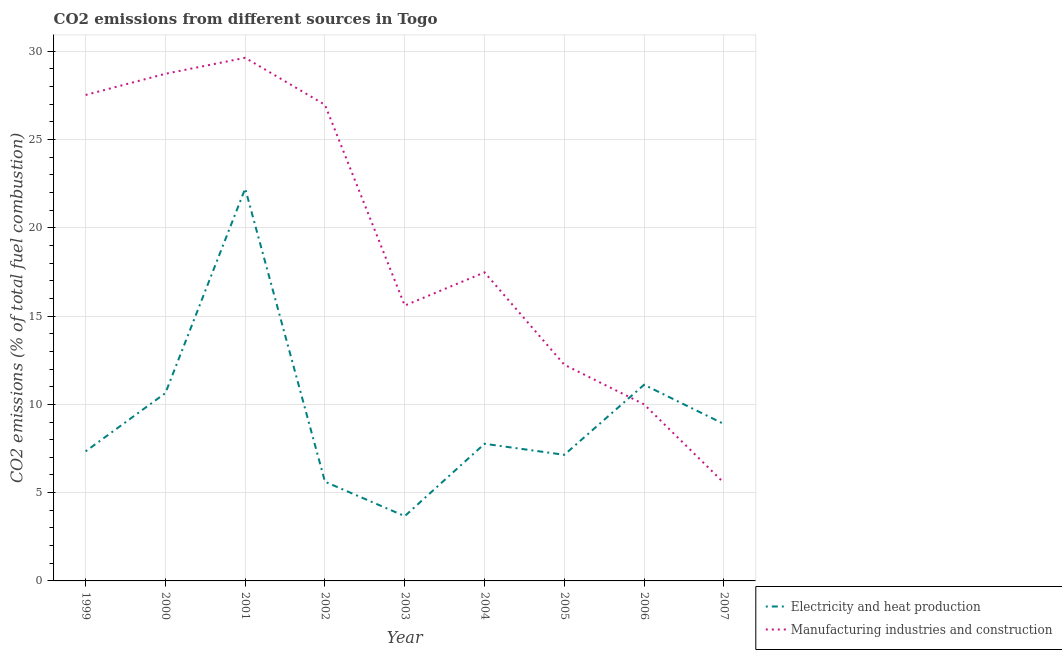Does the line corresponding to co2 emissions due to electricity and heat production intersect with the line corresponding to co2 emissions due to manufacturing industries?
Provide a succinct answer. Yes. What is the co2 emissions due to electricity and heat production in 2005?
Provide a succinct answer. 7.14. Across all years, what is the maximum co2 emissions due to manufacturing industries?
Provide a succinct answer. 29.63. Across all years, what is the minimum co2 emissions due to electricity and heat production?
Ensure brevity in your answer.  3.67. In which year was the co2 emissions due to manufacturing industries maximum?
Provide a succinct answer. 2001. In which year was the co2 emissions due to electricity and heat production minimum?
Offer a very short reply. 2003. What is the total co2 emissions due to electricity and heat production in the graph?
Make the answer very short. 84.4. What is the difference between the co2 emissions due to manufacturing industries in 2003 and that in 2007?
Ensure brevity in your answer.  10.04. What is the difference between the co2 emissions due to electricity and heat production in 2003 and the co2 emissions due to manufacturing industries in 2007?
Your answer should be compact. -1.89. What is the average co2 emissions due to manufacturing industries per year?
Ensure brevity in your answer.  19.3. In the year 2007, what is the difference between the co2 emissions due to manufacturing industries and co2 emissions due to electricity and heat production?
Make the answer very short. -3.33. What is the ratio of the co2 emissions due to manufacturing industries in 2001 to that in 2006?
Provide a short and direct response. 2.96. Is the co2 emissions due to manufacturing industries in 2001 less than that in 2006?
Offer a very short reply. No. What is the difference between the highest and the second highest co2 emissions due to electricity and heat production?
Provide a succinct answer. 11.11. What is the difference between the highest and the lowest co2 emissions due to manufacturing industries?
Provide a short and direct response. 24.07. Is the co2 emissions due to electricity and heat production strictly greater than the co2 emissions due to manufacturing industries over the years?
Your answer should be very brief. No. Does the graph contain any zero values?
Your answer should be compact. No. How many legend labels are there?
Make the answer very short. 2. What is the title of the graph?
Offer a terse response. CO2 emissions from different sources in Togo. What is the label or title of the Y-axis?
Make the answer very short. CO2 emissions (% of total fuel combustion). What is the CO2 emissions (% of total fuel combustion) in Electricity and heat production in 1999?
Your response must be concise. 7.34. What is the CO2 emissions (% of total fuel combustion) of Manufacturing industries and construction in 1999?
Make the answer very short. 27.52. What is the CO2 emissions (% of total fuel combustion) in Electricity and heat production in 2000?
Your answer should be compact. 10.64. What is the CO2 emissions (% of total fuel combustion) in Manufacturing industries and construction in 2000?
Provide a succinct answer. 28.72. What is the CO2 emissions (% of total fuel combustion) in Electricity and heat production in 2001?
Offer a very short reply. 22.22. What is the CO2 emissions (% of total fuel combustion) of Manufacturing industries and construction in 2001?
Offer a very short reply. 29.63. What is the CO2 emissions (% of total fuel combustion) in Electricity and heat production in 2002?
Give a very brief answer. 5.62. What is the CO2 emissions (% of total fuel combustion) in Manufacturing industries and construction in 2002?
Give a very brief answer. 26.97. What is the CO2 emissions (% of total fuel combustion) of Electricity and heat production in 2003?
Keep it short and to the point. 3.67. What is the CO2 emissions (% of total fuel combustion) in Manufacturing industries and construction in 2003?
Provide a short and direct response. 15.6. What is the CO2 emissions (% of total fuel combustion) of Electricity and heat production in 2004?
Offer a very short reply. 7.77. What is the CO2 emissions (% of total fuel combustion) in Manufacturing industries and construction in 2004?
Your answer should be very brief. 17.48. What is the CO2 emissions (% of total fuel combustion) of Electricity and heat production in 2005?
Give a very brief answer. 7.14. What is the CO2 emissions (% of total fuel combustion) of Manufacturing industries and construction in 2005?
Your answer should be compact. 12.24. What is the CO2 emissions (% of total fuel combustion) of Electricity and heat production in 2006?
Offer a terse response. 11.11. What is the CO2 emissions (% of total fuel combustion) of Electricity and heat production in 2007?
Ensure brevity in your answer.  8.89. What is the CO2 emissions (% of total fuel combustion) of Manufacturing industries and construction in 2007?
Your answer should be very brief. 5.56. Across all years, what is the maximum CO2 emissions (% of total fuel combustion) in Electricity and heat production?
Make the answer very short. 22.22. Across all years, what is the maximum CO2 emissions (% of total fuel combustion) in Manufacturing industries and construction?
Ensure brevity in your answer.  29.63. Across all years, what is the minimum CO2 emissions (% of total fuel combustion) in Electricity and heat production?
Offer a very short reply. 3.67. Across all years, what is the minimum CO2 emissions (% of total fuel combustion) in Manufacturing industries and construction?
Your response must be concise. 5.56. What is the total CO2 emissions (% of total fuel combustion) of Electricity and heat production in the graph?
Give a very brief answer. 84.4. What is the total CO2 emissions (% of total fuel combustion) of Manufacturing industries and construction in the graph?
Keep it short and to the point. 173.71. What is the difference between the CO2 emissions (% of total fuel combustion) of Electricity and heat production in 1999 and that in 2000?
Keep it short and to the point. -3.3. What is the difference between the CO2 emissions (% of total fuel combustion) in Manufacturing industries and construction in 1999 and that in 2000?
Your response must be concise. -1.2. What is the difference between the CO2 emissions (% of total fuel combustion) of Electricity and heat production in 1999 and that in 2001?
Offer a very short reply. -14.88. What is the difference between the CO2 emissions (% of total fuel combustion) of Manufacturing industries and construction in 1999 and that in 2001?
Make the answer very short. -2.11. What is the difference between the CO2 emissions (% of total fuel combustion) in Electricity and heat production in 1999 and that in 2002?
Your response must be concise. 1.72. What is the difference between the CO2 emissions (% of total fuel combustion) in Manufacturing industries and construction in 1999 and that in 2002?
Your answer should be very brief. 0.56. What is the difference between the CO2 emissions (% of total fuel combustion) in Electricity and heat production in 1999 and that in 2003?
Ensure brevity in your answer.  3.67. What is the difference between the CO2 emissions (% of total fuel combustion) in Manufacturing industries and construction in 1999 and that in 2003?
Make the answer very short. 11.93. What is the difference between the CO2 emissions (% of total fuel combustion) of Electricity and heat production in 1999 and that in 2004?
Provide a succinct answer. -0.43. What is the difference between the CO2 emissions (% of total fuel combustion) of Manufacturing industries and construction in 1999 and that in 2004?
Provide a short and direct response. 10.05. What is the difference between the CO2 emissions (% of total fuel combustion) of Electricity and heat production in 1999 and that in 2005?
Keep it short and to the point. 0.2. What is the difference between the CO2 emissions (% of total fuel combustion) of Manufacturing industries and construction in 1999 and that in 2005?
Make the answer very short. 15.28. What is the difference between the CO2 emissions (% of total fuel combustion) of Electricity and heat production in 1999 and that in 2006?
Keep it short and to the point. -3.77. What is the difference between the CO2 emissions (% of total fuel combustion) of Manufacturing industries and construction in 1999 and that in 2006?
Offer a very short reply. 17.52. What is the difference between the CO2 emissions (% of total fuel combustion) of Electricity and heat production in 1999 and that in 2007?
Provide a short and direct response. -1.55. What is the difference between the CO2 emissions (% of total fuel combustion) of Manufacturing industries and construction in 1999 and that in 2007?
Your answer should be compact. 21.97. What is the difference between the CO2 emissions (% of total fuel combustion) of Electricity and heat production in 2000 and that in 2001?
Offer a very short reply. -11.58. What is the difference between the CO2 emissions (% of total fuel combustion) of Manufacturing industries and construction in 2000 and that in 2001?
Your answer should be compact. -0.91. What is the difference between the CO2 emissions (% of total fuel combustion) in Electricity and heat production in 2000 and that in 2002?
Ensure brevity in your answer.  5.02. What is the difference between the CO2 emissions (% of total fuel combustion) of Manufacturing industries and construction in 2000 and that in 2002?
Offer a very short reply. 1.76. What is the difference between the CO2 emissions (% of total fuel combustion) of Electricity and heat production in 2000 and that in 2003?
Keep it short and to the point. 6.97. What is the difference between the CO2 emissions (% of total fuel combustion) of Manufacturing industries and construction in 2000 and that in 2003?
Give a very brief answer. 13.13. What is the difference between the CO2 emissions (% of total fuel combustion) of Electricity and heat production in 2000 and that in 2004?
Ensure brevity in your answer.  2.87. What is the difference between the CO2 emissions (% of total fuel combustion) in Manufacturing industries and construction in 2000 and that in 2004?
Keep it short and to the point. 11.25. What is the difference between the CO2 emissions (% of total fuel combustion) in Electricity and heat production in 2000 and that in 2005?
Your response must be concise. 3.5. What is the difference between the CO2 emissions (% of total fuel combustion) of Manufacturing industries and construction in 2000 and that in 2005?
Give a very brief answer. 16.48. What is the difference between the CO2 emissions (% of total fuel combustion) of Electricity and heat production in 2000 and that in 2006?
Offer a terse response. -0.47. What is the difference between the CO2 emissions (% of total fuel combustion) of Manufacturing industries and construction in 2000 and that in 2006?
Your response must be concise. 18.72. What is the difference between the CO2 emissions (% of total fuel combustion) in Electricity and heat production in 2000 and that in 2007?
Your answer should be compact. 1.75. What is the difference between the CO2 emissions (% of total fuel combustion) in Manufacturing industries and construction in 2000 and that in 2007?
Give a very brief answer. 23.17. What is the difference between the CO2 emissions (% of total fuel combustion) in Electricity and heat production in 2001 and that in 2002?
Give a very brief answer. 16.6. What is the difference between the CO2 emissions (% of total fuel combustion) in Manufacturing industries and construction in 2001 and that in 2002?
Your response must be concise. 2.66. What is the difference between the CO2 emissions (% of total fuel combustion) in Electricity and heat production in 2001 and that in 2003?
Provide a short and direct response. 18.55. What is the difference between the CO2 emissions (% of total fuel combustion) in Manufacturing industries and construction in 2001 and that in 2003?
Keep it short and to the point. 14.03. What is the difference between the CO2 emissions (% of total fuel combustion) in Electricity and heat production in 2001 and that in 2004?
Offer a very short reply. 14.46. What is the difference between the CO2 emissions (% of total fuel combustion) in Manufacturing industries and construction in 2001 and that in 2004?
Give a very brief answer. 12.15. What is the difference between the CO2 emissions (% of total fuel combustion) of Electricity and heat production in 2001 and that in 2005?
Make the answer very short. 15.08. What is the difference between the CO2 emissions (% of total fuel combustion) of Manufacturing industries and construction in 2001 and that in 2005?
Your answer should be compact. 17.38. What is the difference between the CO2 emissions (% of total fuel combustion) in Electricity and heat production in 2001 and that in 2006?
Your response must be concise. 11.11. What is the difference between the CO2 emissions (% of total fuel combustion) in Manufacturing industries and construction in 2001 and that in 2006?
Make the answer very short. 19.63. What is the difference between the CO2 emissions (% of total fuel combustion) in Electricity and heat production in 2001 and that in 2007?
Your answer should be compact. 13.33. What is the difference between the CO2 emissions (% of total fuel combustion) of Manufacturing industries and construction in 2001 and that in 2007?
Your answer should be very brief. 24.07. What is the difference between the CO2 emissions (% of total fuel combustion) in Electricity and heat production in 2002 and that in 2003?
Make the answer very short. 1.95. What is the difference between the CO2 emissions (% of total fuel combustion) in Manufacturing industries and construction in 2002 and that in 2003?
Your response must be concise. 11.37. What is the difference between the CO2 emissions (% of total fuel combustion) in Electricity and heat production in 2002 and that in 2004?
Make the answer very short. -2.15. What is the difference between the CO2 emissions (% of total fuel combustion) of Manufacturing industries and construction in 2002 and that in 2004?
Make the answer very short. 9.49. What is the difference between the CO2 emissions (% of total fuel combustion) in Electricity and heat production in 2002 and that in 2005?
Make the answer very short. -1.52. What is the difference between the CO2 emissions (% of total fuel combustion) in Manufacturing industries and construction in 2002 and that in 2005?
Provide a short and direct response. 14.72. What is the difference between the CO2 emissions (% of total fuel combustion) in Electricity and heat production in 2002 and that in 2006?
Provide a short and direct response. -5.49. What is the difference between the CO2 emissions (% of total fuel combustion) in Manufacturing industries and construction in 2002 and that in 2006?
Your response must be concise. 16.97. What is the difference between the CO2 emissions (% of total fuel combustion) of Electricity and heat production in 2002 and that in 2007?
Ensure brevity in your answer.  -3.27. What is the difference between the CO2 emissions (% of total fuel combustion) in Manufacturing industries and construction in 2002 and that in 2007?
Give a very brief answer. 21.41. What is the difference between the CO2 emissions (% of total fuel combustion) of Electricity and heat production in 2003 and that in 2004?
Your response must be concise. -4.1. What is the difference between the CO2 emissions (% of total fuel combustion) in Manufacturing industries and construction in 2003 and that in 2004?
Offer a terse response. -1.88. What is the difference between the CO2 emissions (% of total fuel combustion) in Electricity and heat production in 2003 and that in 2005?
Keep it short and to the point. -3.47. What is the difference between the CO2 emissions (% of total fuel combustion) of Manufacturing industries and construction in 2003 and that in 2005?
Give a very brief answer. 3.35. What is the difference between the CO2 emissions (% of total fuel combustion) in Electricity and heat production in 2003 and that in 2006?
Give a very brief answer. -7.44. What is the difference between the CO2 emissions (% of total fuel combustion) of Manufacturing industries and construction in 2003 and that in 2006?
Offer a terse response. 5.6. What is the difference between the CO2 emissions (% of total fuel combustion) of Electricity and heat production in 2003 and that in 2007?
Ensure brevity in your answer.  -5.22. What is the difference between the CO2 emissions (% of total fuel combustion) of Manufacturing industries and construction in 2003 and that in 2007?
Make the answer very short. 10.04. What is the difference between the CO2 emissions (% of total fuel combustion) of Electricity and heat production in 2004 and that in 2005?
Offer a terse response. 0.62. What is the difference between the CO2 emissions (% of total fuel combustion) of Manufacturing industries and construction in 2004 and that in 2005?
Give a very brief answer. 5.23. What is the difference between the CO2 emissions (% of total fuel combustion) in Electricity and heat production in 2004 and that in 2006?
Give a very brief answer. -3.34. What is the difference between the CO2 emissions (% of total fuel combustion) in Manufacturing industries and construction in 2004 and that in 2006?
Your answer should be very brief. 7.48. What is the difference between the CO2 emissions (% of total fuel combustion) in Electricity and heat production in 2004 and that in 2007?
Provide a succinct answer. -1.12. What is the difference between the CO2 emissions (% of total fuel combustion) of Manufacturing industries and construction in 2004 and that in 2007?
Your answer should be very brief. 11.92. What is the difference between the CO2 emissions (% of total fuel combustion) of Electricity and heat production in 2005 and that in 2006?
Offer a very short reply. -3.97. What is the difference between the CO2 emissions (% of total fuel combustion) of Manufacturing industries and construction in 2005 and that in 2006?
Ensure brevity in your answer.  2.24. What is the difference between the CO2 emissions (% of total fuel combustion) of Electricity and heat production in 2005 and that in 2007?
Keep it short and to the point. -1.75. What is the difference between the CO2 emissions (% of total fuel combustion) in Manufacturing industries and construction in 2005 and that in 2007?
Keep it short and to the point. 6.69. What is the difference between the CO2 emissions (% of total fuel combustion) of Electricity and heat production in 2006 and that in 2007?
Offer a very short reply. 2.22. What is the difference between the CO2 emissions (% of total fuel combustion) in Manufacturing industries and construction in 2006 and that in 2007?
Provide a short and direct response. 4.44. What is the difference between the CO2 emissions (% of total fuel combustion) in Electricity and heat production in 1999 and the CO2 emissions (% of total fuel combustion) in Manufacturing industries and construction in 2000?
Your answer should be compact. -21.38. What is the difference between the CO2 emissions (% of total fuel combustion) of Electricity and heat production in 1999 and the CO2 emissions (% of total fuel combustion) of Manufacturing industries and construction in 2001?
Your answer should be compact. -22.29. What is the difference between the CO2 emissions (% of total fuel combustion) of Electricity and heat production in 1999 and the CO2 emissions (% of total fuel combustion) of Manufacturing industries and construction in 2002?
Provide a succinct answer. -19.63. What is the difference between the CO2 emissions (% of total fuel combustion) of Electricity and heat production in 1999 and the CO2 emissions (% of total fuel combustion) of Manufacturing industries and construction in 2003?
Make the answer very short. -8.26. What is the difference between the CO2 emissions (% of total fuel combustion) of Electricity and heat production in 1999 and the CO2 emissions (% of total fuel combustion) of Manufacturing industries and construction in 2004?
Your response must be concise. -10.14. What is the difference between the CO2 emissions (% of total fuel combustion) in Electricity and heat production in 1999 and the CO2 emissions (% of total fuel combustion) in Manufacturing industries and construction in 2005?
Offer a very short reply. -4.91. What is the difference between the CO2 emissions (% of total fuel combustion) of Electricity and heat production in 1999 and the CO2 emissions (% of total fuel combustion) of Manufacturing industries and construction in 2006?
Your answer should be compact. -2.66. What is the difference between the CO2 emissions (% of total fuel combustion) in Electricity and heat production in 1999 and the CO2 emissions (% of total fuel combustion) in Manufacturing industries and construction in 2007?
Your answer should be compact. 1.78. What is the difference between the CO2 emissions (% of total fuel combustion) in Electricity and heat production in 2000 and the CO2 emissions (% of total fuel combustion) in Manufacturing industries and construction in 2001?
Provide a succinct answer. -18.99. What is the difference between the CO2 emissions (% of total fuel combustion) in Electricity and heat production in 2000 and the CO2 emissions (% of total fuel combustion) in Manufacturing industries and construction in 2002?
Offer a terse response. -16.33. What is the difference between the CO2 emissions (% of total fuel combustion) of Electricity and heat production in 2000 and the CO2 emissions (% of total fuel combustion) of Manufacturing industries and construction in 2003?
Offer a very short reply. -4.96. What is the difference between the CO2 emissions (% of total fuel combustion) in Electricity and heat production in 2000 and the CO2 emissions (% of total fuel combustion) in Manufacturing industries and construction in 2004?
Make the answer very short. -6.84. What is the difference between the CO2 emissions (% of total fuel combustion) of Electricity and heat production in 2000 and the CO2 emissions (% of total fuel combustion) of Manufacturing industries and construction in 2005?
Ensure brevity in your answer.  -1.61. What is the difference between the CO2 emissions (% of total fuel combustion) of Electricity and heat production in 2000 and the CO2 emissions (% of total fuel combustion) of Manufacturing industries and construction in 2006?
Your answer should be compact. 0.64. What is the difference between the CO2 emissions (% of total fuel combustion) of Electricity and heat production in 2000 and the CO2 emissions (% of total fuel combustion) of Manufacturing industries and construction in 2007?
Give a very brief answer. 5.08. What is the difference between the CO2 emissions (% of total fuel combustion) of Electricity and heat production in 2001 and the CO2 emissions (% of total fuel combustion) of Manufacturing industries and construction in 2002?
Provide a short and direct response. -4.74. What is the difference between the CO2 emissions (% of total fuel combustion) of Electricity and heat production in 2001 and the CO2 emissions (% of total fuel combustion) of Manufacturing industries and construction in 2003?
Your answer should be compact. 6.63. What is the difference between the CO2 emissions (% of total fuel combustion) of Electricity and heat production in 2001 and the CO2 emissions (% of total fuel combustion) of Manufacturing industries and construction in 2004?
Keep it short and to the point. 4.75. What is the difference between the CO2 emissions (% of total fuel combustion) of Electricity and heat production in 2001 and the CO2 emissions (% of total fuel combustion) of Manufacturing industries and construction in 2005?
Your response must be concise. 9.98. What is the difference between the CO2 emissions (% of total fuel combustion) of Electricity and heat production in 2001 and the CO2 emissions (% of total fuel combustion) of Manufacturing industries and construction in 2006?
Keep it short and to the point. 12.22. What is the difference between the CO2 emissions (% of total fuel combustion) in Electricity and heat production in 2001 and the CO2 emissions (% of total fuel combustion) in Manufacturing industries and construction in 2007?
Keep it short and to the point. 16.67. What is the difference between the CO2 emissions (% of total fuel combustion) in Electricity and heat production in 2002 and the CO2 emissions (% of total fuel combustion) in Manufacturing industries and construction in 2003?
Offer a terse response. -9.98. What is the difference between the CO2 emissions (% of total fuel combustion) in Electricity and heat production in 2002 and the CO2 emissions (% of total fuel combustion) in Manufacturing industries and construction in 2004?
Make the answer very short. -11.86. What is the difference between the CO2 emissions (% of total fuel combustion) of Electricity and heat production in 2002 and the CO2 emissions (% of total fuel combustion) of Manufacturing industries and construction in 2005?
Offer a terse response. -6.63. What is the difference between the CO2 emissions (% of total fuel combustion) in Electricity and heat production in 2002 and the CO2 emissions (% of total fuel combustion) in Manufacturing industries and construction in 2006?
Ensure brevity in your answer.  -4.38. What is the difference between the CO2 emissions (% of total fuel combustion) of Electricity and heat production in 2002 and the CO2 emissions (% of total fuel combustion) of Manufacturing industries and construction in 2007?
Offer a terse response. 0.06. What is the difference between the CO2 emissions (% of total fuel combustion) in Electricity and heat production in 2003 and the CO2 emissions (% of total fuel combustion) in Manufacturing industries and construction in 2004?
Offer a terse response. -13.81. What is the difference between the CO2 emissions (% of total fuel combustion) in Electricity and heat production in 2003 and the CO2 emissions (% of total fuel combustion) in Manufacturing industries and construction in 2005?
Your answer should be very brief. -8.58. What is the difference between the CO2 emissions (% of total fuel combustion) in Electricity and heat production in 2003 and the CO2 emissions (% of total fuel combustion) in Manufacturing industries and construction in 2006?
Your response must be concise. -6.33. What is the difference between the CO2 emissions (% of total fuel combustion) in Electricity and heat production in 2003 and the CO2 emissions (% of total fuel combustion) in Manufacturing industries and construction in 2007?
Your answer should be compact. -1.89. What is the difference between the CO2 emissions (% of total fuel combustion) of Electricity and heat production in 2004 and the CO2 emissions (% of total fuel combustion) of Manufacturing industries and construction in 2005?
Your answer should be very brief. -4.48. What is the difference between the CO2 emissions (% of total fuel combustion) in Electricity and heat production in 2004 and the CO2 emissions (% of total fuel combustion) in Manufacturing industries and construction in 2006?
Ensure brevity in your answer.  -2.23. What is the difference between the CO2 emissions (% of total fuel combustion) in Electricity and heat production in 2004 and the CO2 emissions (% of total fuel combustion) in Manufacturing industries and construction in 2007?
Your response must be concise. 2.21. What is the difference between the CO2 emissions (% of total fuel combustion) in Electricity and heat production in 2005 and the CO2 emissions (% of total fuel combustion) in Manufacturing industries and construction in 2006?
Provide a succinct answer. -2.86. What is the difference between the CO2 emissions (% of total fuel combustion) in Electricity and heat production in 2005 and the CO2 emissions (% of total fuel combustion) in Manufacturing industries and construction in 2007?
Offer a very short reply. 1.59. What is the difference between the CO2 emissions (% of total fuel combustion) in Electricity and heat production in 2006 and the CO2 emissions (% of total fuel combustion) in Manufacturing industries and construction in 2007?
Provide a short and direct response. 5.56. What is the average CO2 emissions (% of total fuel combustion) of Electricity and heat production per year?
Your answer should be very brief. 9.38. What is the average CO2 emissions (% of total fuel combustion) of Manufacturing industries and construction per year?
Ensure brevity in your answer.  19.3. In the year 1999, what is the difference between the CO2 emissions (% of total fuel combustion) of Electricity and heat production and CO2 emissions (% of total fuel combustion) of Manufacturing industries and construction?
Give a very brief answer. -20.18. In the year 2000, what is the difference between the CO2 emissions (% of total fuel combustion) of Electricity and heat production and CO2 emissions (% of total fuel combustion) of Manufacturing industries and construction?
Your answer should be very brief. -18.09. In the year 2001, what is the difference between the CO2 emissions (% of total fuel combustion) in Electricity and heat production and CO2 emissions (% of total fuel combustion) in Manufacturing industries and construction?
Your response must be concise. -7.41. In the year 2002, what is the difference between the CO2 emissions (% of total fuel combustion) of Electricity and heat production and CO2 emissions (% of total fuel combustion) of Manufacturing industries and construction?
Offer a very short reply. -21.35. In the year 2003, what is the difference between the CO2 emissions (% of total fuel combustion) in Electricity and heat production and CO2 emissions (% of total fuel combustion) in Manufacturing industries and construction?
Make the answer very short. -11.93. In the year 2004, what is the difference between the CO2 emissions (% of total fuel combustion) in Electricity and heat production and CO2 emissions (% of total fuel combustion) in Manufacturing industries and construction?
Ensure brevity in your answer.  -9.71. In the year 2005, what is the difference between the CO2 emissions (% of total fuel combustion) of Electricity and heat production and CO2 emissions (% of total fuel combustion) of Manufacturing industries and construction?
Provide a succinct answer. -5.1. What is the ratio of the CO2 emissions (% of total fuel combustion) of Electricity and heat production in 1999 to that in 2000?
Keep it short and to the point. 0.69. What is the ratio of the CO2 emissions (% of total fuel combustion) in Manufacturing industries and construction in 1999 to that in 2000?
Offer a very short reply. 0.96. What is the ratio of the CO2 emissions (% of total fuel combustion) of Electricity and heat production in 1999 to that in 2001?
Offer a very short reply. 0.33. What is the ratio of the CO2 emissions (% of total fuel combustion) in Manufacturing industries and construction in 1999 to that in 2001?
Give a very brief answer. 0.93. What is the ratio of the CO2 emissions (% of total fuel combustion) of Electricity and heat production in 1999 to that in 2002?
Offer a very short reply. 1.31. What is the ratio of the CO2 emissions (% of total fuel combustion) in Manufacturing industries and construction in 1999 to that in 2002?
Your answer should be very brief. 1.02. What is the ratio of the CO2 emissions (% of total fuel combustion) in Electricity and heat production in 1999 to that in 2003?
Provide a short and direct response. 2. What is the ratio of the CO2 emissions (% of total fuel combustion) of Manufacturing industries and construction in 1999 to that in 2003?
Offer a very short reply. 1.76. What is the ratio of the CO2 emissions (% of total fuel combustion) in Electricity and heat production in 1999 to that in 2004?
Provide a succinct answer. 0.94. What is the ratio of the CO2 emissions (% of total fuel combustion) of Manufacturing industries and construction in 1999 to that in 2004?
Provide a succinct answer. 1.57. What is the ratio of the CO2 emissions (% of total fuel combustion) of Electricity and heat production in 1999 to that in 2005?
Make the answer very short. 1.03. What is the ratio of the CO2 emissions (% of total fuel combustion) of Manufacturing industries and construction in 1999 to that in 2005?
Provide a succinct answer. 2.25. What is the ratio of the CO2 emissions (% of total fuel combustion) in Electricity and heat production in 1999 to that in 2006?
Provide a short and direct response. 0.66. What is the ratio of the CO2 emissions (% of total fuel combustion) in Manufacturing industries and construction in 1999 to that in 2006?
Your answer should be very brief. 2.75. What is the ratio of the CO2 emissions (% of total fuel combustion) in Electricity and heat production in 1999 to that in 2007?
Ensure brevity in your answer.  0.83. What is the ratio of the CO2 emissions (% of total fuel combustion) in Manufacturing industries and construction in 1999 to that in 2007?
Give a very brief answer. 4.95. What is the ratio of the CO2 emissions (% of total fuel combustion) in Electricity and heat production in 2000 to that in 2001?
Provide a succinct answer. 0.48. What is the ratio of the CO2 emissions (% of total fuel combustion) of Manufacturing industries and construction in 2000 to that in 2001?
Offer a terse response. 0.97. What is the ratio of the CO2 emissions (% of total fuel combustion) in Electricity and heat production in 2000 to that in 2002?
Your answer should be very brief. 1.89. What is the ratio of the CO2 emissions (% of total fuel combustion) in Manufacturing industries and construction in 2000 to that in 2002?
Your response must be concise. 1.07. What is the ratio of the CO2 emissions (% of total fuel combustion) of Electricity and heat production in 2000 to that in 2003?
Offer a very short reply. 2.9. What is the ratio of the CO2 emissions (% of total fuel combustion) in Manufacturing industries and construction in 2000 to that in 2003?
Ensure brevity in your answer.  1.84. What is the ratio of the CO2 emissions (% of total fuel combustion) in Electricity and heat production in 2000 to that in 2004?
Offer a very short reply. 1.37. What is the ratio of the CO2 emissions (% of total fuel combustion) of Manufacturing industries and construction in 2000 to that in 2004?
Your response must be concise. 1.64. What is the ratio of the CO2 emissions (% of total fuel combustion) in Electricity and heat production in 2000 to that in 2005?
Offer a very short reply. 1.49. What is the ratio of the CO2 emissions (% of total fuel combustion) in Manufacturing industries and construction in 2000 to that in 2005?
Keep it short and to the point. 2.35. What is the ratio of the CO2 emissions (% of total fuel combustion) in Electricity and heat production in 2000 to that in 2006?
Ensure brevity in your answer.  0.96. What is the ratio of the CO2 emissions (% of total fuel combustion) in Manufacturing industries and construction in 2000 to that in 2006?
Provide a short and direct response. 2.87. What is the ratio of the CO2 emissions (% of total fuel combustion) in Electricity and heat production in 2000 to that in 2007?
Your response must be concise. 1.2. What is the ratio of the CO2 emissions (% of total fuel combustion) of Manufacturing industries and construction in 2000 to that in 2007?
Give a very brief answer. 5.17. What is the ratio of the CO2 emissions (% of total fuel combustion) in Electricity and heat production in 2001 to that in 2002?
Offer a terse response. 3.96. What is the ratio of the CO2 emissions (% of total fuel combustion) in Manufacturing industries and construction in 2001 to that in 2002?
Provide a short and direct response. 1.1. What is the ratio of the CO2 emissions (% of total fuel combustion) in Electricity and heat production in 2001 to that in 2003?
Your answer should be compact. 6.06. What is the ratio of the CO2 emissions (% of total fuel combustion) in Manufacturing industries and construction in 2001 to that in 2003?
Ensure brevity in your answer.  1.9. What is the ratio of the CO2 emissions (% of total fuel combustion) of Electricity and heat production in 2001 to that in 2004?
Offer a terse response. 2.86. What is the ratio of the CO2 emissions (% of total fuel combustion) of Manufacturing industries and construction in 2001 to that in 2004?
Your answer should be very brief. 1.7. What is the ratio of the CO2 emissions (% of total fuel combustion) in Electricity and heat production in 2001 to that in 2005?
Offer a terse response. 3.11. What is the ratio of the CO2 emissions (% of total fuel combustion) in Manufacturing industries and construction in 2001 to that in 2005?
Your answer should be compact. 2.42. What is the ratio of the CO2 emissions (% of total fuel combustion) in Electricity and heat production in 2001 to that in 2006?
Make the answer very short. 2. What is the ratio of the CO2 emissions (% of total fuel combustion) in Manufacturing industries and construction in 2001 to that in 2006?
Offer a very short reply. 2.96. What is the ratio of the CO2 emissions (% of total fuel combustion) of Manufacturing industries and construction in 2001 to that in 2007?
Give a very brief answer. 5.33. What is the ratio of the CO2 emissions (% of total fuel combustion) in Electricity and heat production in 2002 to that in 2003?
Your answer should be compact. 1.53. What is the ratio of the CO2 emissions (% of total fuel combustion) of Manufacturing industries and construction in 2002 to that in 2003?
Offer a terse response. 1.73. What is the ratio of the CO2 emissions (% of total fuel combustion) in Electricity and heat production in 2002 to that in 2004?
Make the answer very short. 0.72. What is the ratio of the CO2 emissions (% of total fuel combustion) of Manufacturing industries and construction in 2002 to that in 2004?
Ensure brevity in your answer.  1.54. What is the ratio of the CO2 emissions (% of total fuel combustion) of Electricity and heat production in 2002 to that in 2005?
Keep it short and to the point. 0.79. What is the ratio of the CO2 emissions (% of total fuel combustion) of Manufacturing industries and construction in 2002 to that in 2005?
Your response must be concise. 2.2. What is the ratio of the CO2 emissions (% of total fuel combustion) of Electricity and heat production in 2002 to that in 2006?
Your answer should be compact. 0.51. What is the ratio of the CO2 emissions (% of total fuel combustion) of Manufacturing industries and construction in 2002 to that in 2006?
Provide a succinct answer. 2.7. What is the ratio of the CO2 emissions (% of total fuel combustion) in Electricity and heat production in 2002 to that in 2007?
Offer a very short reply. 0.63. What is the ratio of the CO2 emissions (% of total fuel combustion) of Manufacturing industries and construction in 2002 to that in 2007?
Provide a succinct answer. 4.85. What is the ratio of the CO2 emissions (% of total fuel combustion) of Electricity and heat production in 2003 to that in 2004?
Offer a terse response. 0.47. What is the ratio of the CO2 emissions (% of total fuel combustion) in Manufacturing industries and construction in 2003 to that in 2004?
Your answer should be compact. 0.89. What is the ratio of the CO2 emissions (% of total fuel combustion) of Electricity and heat production in 2003 to that in 2005?
Your answer should be very brief. 0.51. What is the ratio of the CO2 emissions (% of total fuel combustion) of Manufacturing industries and construction in 2003 to that in 2005?
Your response must be concise. 1.27. What is the ratio of the CO2 emissions (% of total fuel combustion) in Electricity and heat production in 2003 to that in 2006?
Give a very brief answer. 0.33. What is the ratio of the CO2 emissions (% of total fuel combustion) in Manufacturing industries and construction in 2003 to that in 2006?
Give a very brief answer. 1.56. What is the ratio of the CO2 emissions (% of total fuel combustion) of Electricity and heat production in 2003 to that in 2007?
Your answer should be very brief. 0.41. What is the ratio of the CO2 emissions (% of total fuel combustion) of Manufacturing industries and construction in 2003 to that in 2007?
Provide a short and direct response. 2.81. What is the ratio of the CO2 emissions (% of total fuel combustion) in Electricity and heat production in 2004 to that in 2005?
Your answer should be compact. 1.09. What is the ratio of the CO2 emissions (% of total fuel combustion) in Manufacturing industries and construction in 2004 to that in 2005?
Make the answer very short. 1.43. What is the ratio of the CO2 emissions (% of total fuel combustion) in Electricity and heat production in 2004 to that in 2006?
Offer a terse response. 0.7. What is the ratio of the CO2 emissions (% of total fuel combustion) of Manufacturing industries and construction in 2004 to that in 2006?
Your response must be concise. 1.75. What is the ratio of the CO2 emissions (% of total fuel combustion) in Electricity and heat production in 2004 to that in 2007?
Make the answer very short. 0.87. What is the ratio of the CO2 emissions (% of total fuel combustion) of Manufacturing industries and construction in 2004 to that in 2007?
Your response must be concise. 3.15. What is the ratio of the CO2 emissions (% of total fuel combustion) in Electricity and heat production in 2005 to that in 2006?
Provide a short and direct response. 0.64. What is the ratio of the CO2 emissions (% of total fuel combustion) in Manufacturing industries and construction in 2005 to that in 2006?
Your response must be concise. 1.22. What is the ratio of the CO2 emissions (% of total fuel combustion) of Electricity and heat production in 2005 to that in 2007?
Offer a very short reply. 0.8. What is the ratio of the CO2 emissions (% of total fuel combustion) of Manufacturing industries and construction in 2005 to that in 2007?
Your response must be concise. 2.2. What is the ratio of the CO2 emissions (% of total fuel combustion) of Manufacturing industries and construction in 2006 to that in 2007?
Your response must be concise. 1.8. What is the difference between the highest and the second highest CO2 emissions (% of total fuel combustion) of Electricity and heat production?
Give a very brief answer. 11.11. What is the difference between the highest and the second highest CO2 emissions (% of total fuel combustion) of Manufacturing industries and construction?
Your response must be concise. 0.91. What is the difference between the highest and the lowest CO2 emissions (% of total fuel combustion) of Electricity and heat production?
Make the answer very short. 18.55. What is the difference between the highest and the lowest CO2 emissions (% of total fuel combustion) in Manufacturing industries and construction?
Provide a succinct answer. 24.07. 